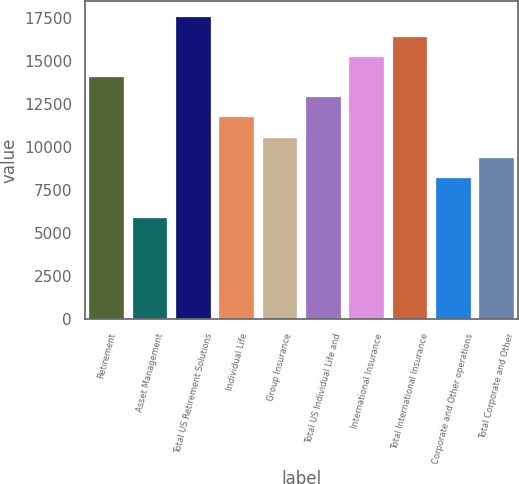Convert chart. <chart><loc_0><loc_0><loc_500><loc_500><bar_chart><fcel>Retirement<fcel>Asset Management<fcel>Total US Retirement Solutions<fcel>Individual Life<fcel>Group Insurance<fcel>Total US Individual Life and<fcel>International Insurance<fcel>Total International Insurance<fcel>Corporate and Other operations<fcel>Total Corporate and Other<nl><fcel>14055.5<fcel>5856.76<fcel>17569.3<fcel>11713<fcel>10541.8<fcel>12884.3<fcel>15226.8<fcel>16398<fcel>8199.26<fcel>9370.51<nl></chart> 